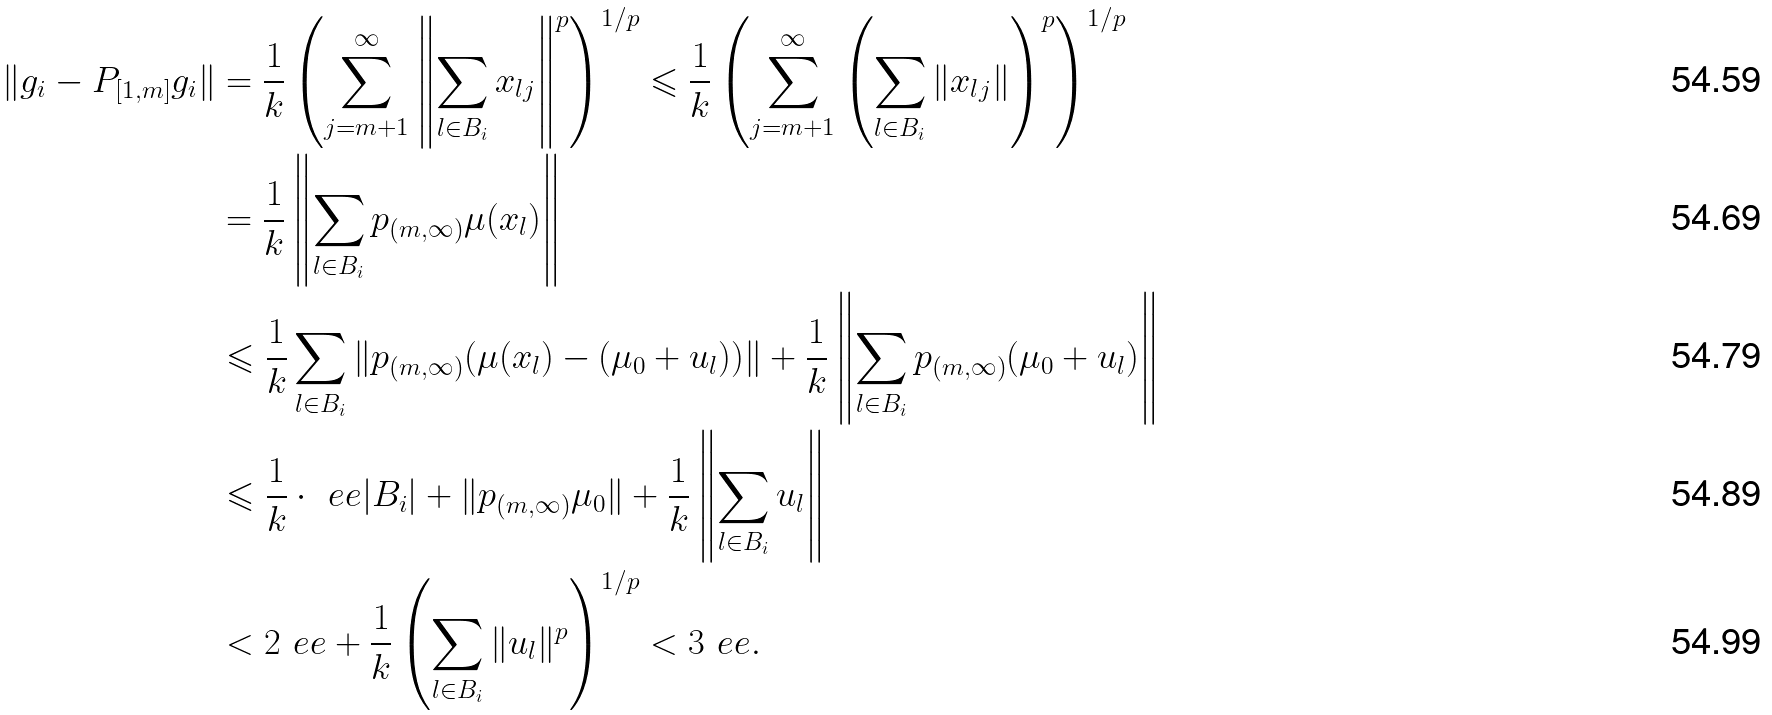Convert formula to latex. <formula><loc_0><loc_0><loc_500><loc_500>\| g _ { i } - P _ { [ 1 , m ] } g _ { i } \| & = \frac { 1 } { k } \left ( \sum _ { j = m + 1 } ^ { \infty } \left \| \sum _ { l \in B _ { i } } x _ { l j } \right \| ^ { p } \right ) ^ { 1 / p } \leqslant \frac { 1 } { k } \left ( \sum _ { j = m + 1 } ^ { \infty } \left ( \sum _ { l \in B _ { i } } \| x _ { l j } \| \right ) ^ { p } \right ) ^ { 1 / p } \\ & = \frac { 1 } { k } \left \| \sum _ { l \in B _ { i } } p _ { ( m , \infty ) } \mu ( x _ { l } ) \right \| \\ & \leqslant \frac { 1 } { k } \sum _ { l \in B _ { i } } \| p _ { ( m , \infty ) } ( \mu ( x _ { l } ) - ( \mu _ { 0 } + u _ { l } ) ) \| + \frac { 1 } { k } \left \| \sum _ { l \in B _ { i } } p _ { ( m , \infty ) } ( \mu _ { 0 } + u _ { l } ) \right \| \\ & \leqslant \frac { 1 } { k } \cdot \ e e | B _ { i } | + \| p _ { ( m , \infty ) } \mu _ { 0 } \| + \frac { 1 } { k } \left \| \sum _ { l \in B _ { i } } u _ { l } \right \| \\ & < 2 \ e e + \frac { 1 } { k } \left ( \sum _ { l \in B _ { i } } \| u _ { l } \| ^ { p } \right ) ^ { 1 / p } < 3 \ e e .</formula> 